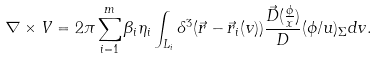<formula> <loc_0><loc_0><loc_500><loc_500>\nabla \times V = 2 \pi \sum _ { i = 1 } ^ { m } \beta _ { i } \eta _ { i } \int _ { L _ { i } } \delta ^ { 3 } ( \vec { r } - \vec { r } _ { i } ( v ) ) \frac { \vec { D } ( \frac { \phi } { x } ) } D ( \phi / u ) _ { \Sigma } d v .</formula> 